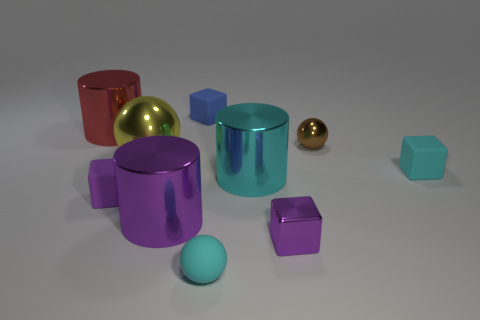Subtract all cylinders. How many objects are left? 7 Add 9 yellow shiny balls. How many yellow shiny balls exist? 10 Subtract 0 yellow cylinders. How many objects are left? 10 Subtract all small brown matte objects. Subtract all cyan metallic cylinders. How many objects are left? 9 Add 3 large cylinders. How many large cylinders are left? 6 